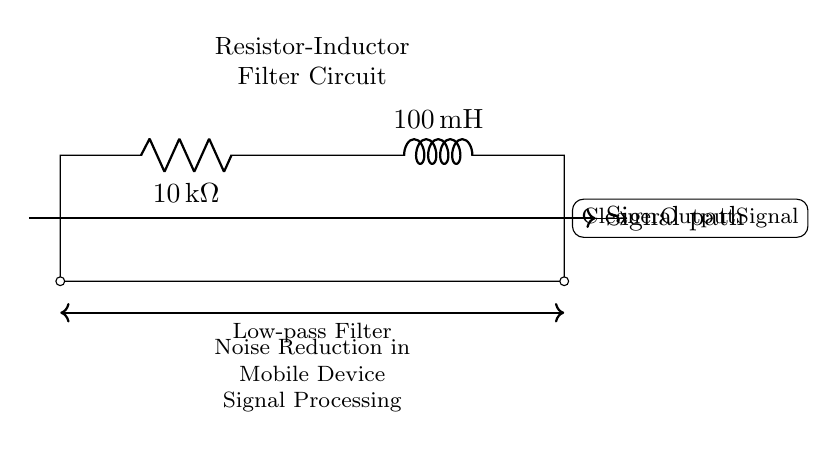What type of filter is this circuit? The circuit diagram shows a low-pass filter, which allows signals with a frequency lower than a certain cutoff frequency to pass while attenuating higher frequencies. This is indicated by the labeling in the circuit.
Answer: Low-pass filter What is the resistance value in this circuit? The resistance value, indicated next to the resistor component in the diagram, is shown as 10 kilo-ohms. This is a direct representation of the resistor's value in the schematic.
Answer: 10 kilo-ohms What is the inductance value in this circuit? The inductance value, marked next to the inductor in the circuit diagram, is 100 milli-Henries. This is the inductor's specified inductance used for filtering purposes.
Answer: 100 milli-Henries How does this circuit affect the output signal? The circuit acts as a filter that cleans the output signal by removing high-frequency noise, resulting in a smoother signal for mobile device processing. This is explicitly stated in the annotations of the circuit diagram.
Answer: Cleaner output signal What are the components used in this circuit? The components used in this Resistor-Inductor filter circuit are a resistor and an inductor. The labels on the diagram clearly identify these components.
Answer: Resistor and inductor What effect does increasing the resistance have on the filter? Increasing the resistance in the circuit would lower the cutoff frequency of the low-pass filter, leading to a greater attenuation of higher frequencies. This modulation of resistance directly affects the filter's performance.
Answer: Lowers cutoff frequency What is the role of the inductor in this circuit? The inductor primarily stores energy in the form of a magnetic field when the current flows through it, which contributes to the filtering effect by opposing changes in current and allowing low-frequency signals to pass. This is typical behavior for inductors in filter applications.
Answer: Stores energy and allows low frequencies 